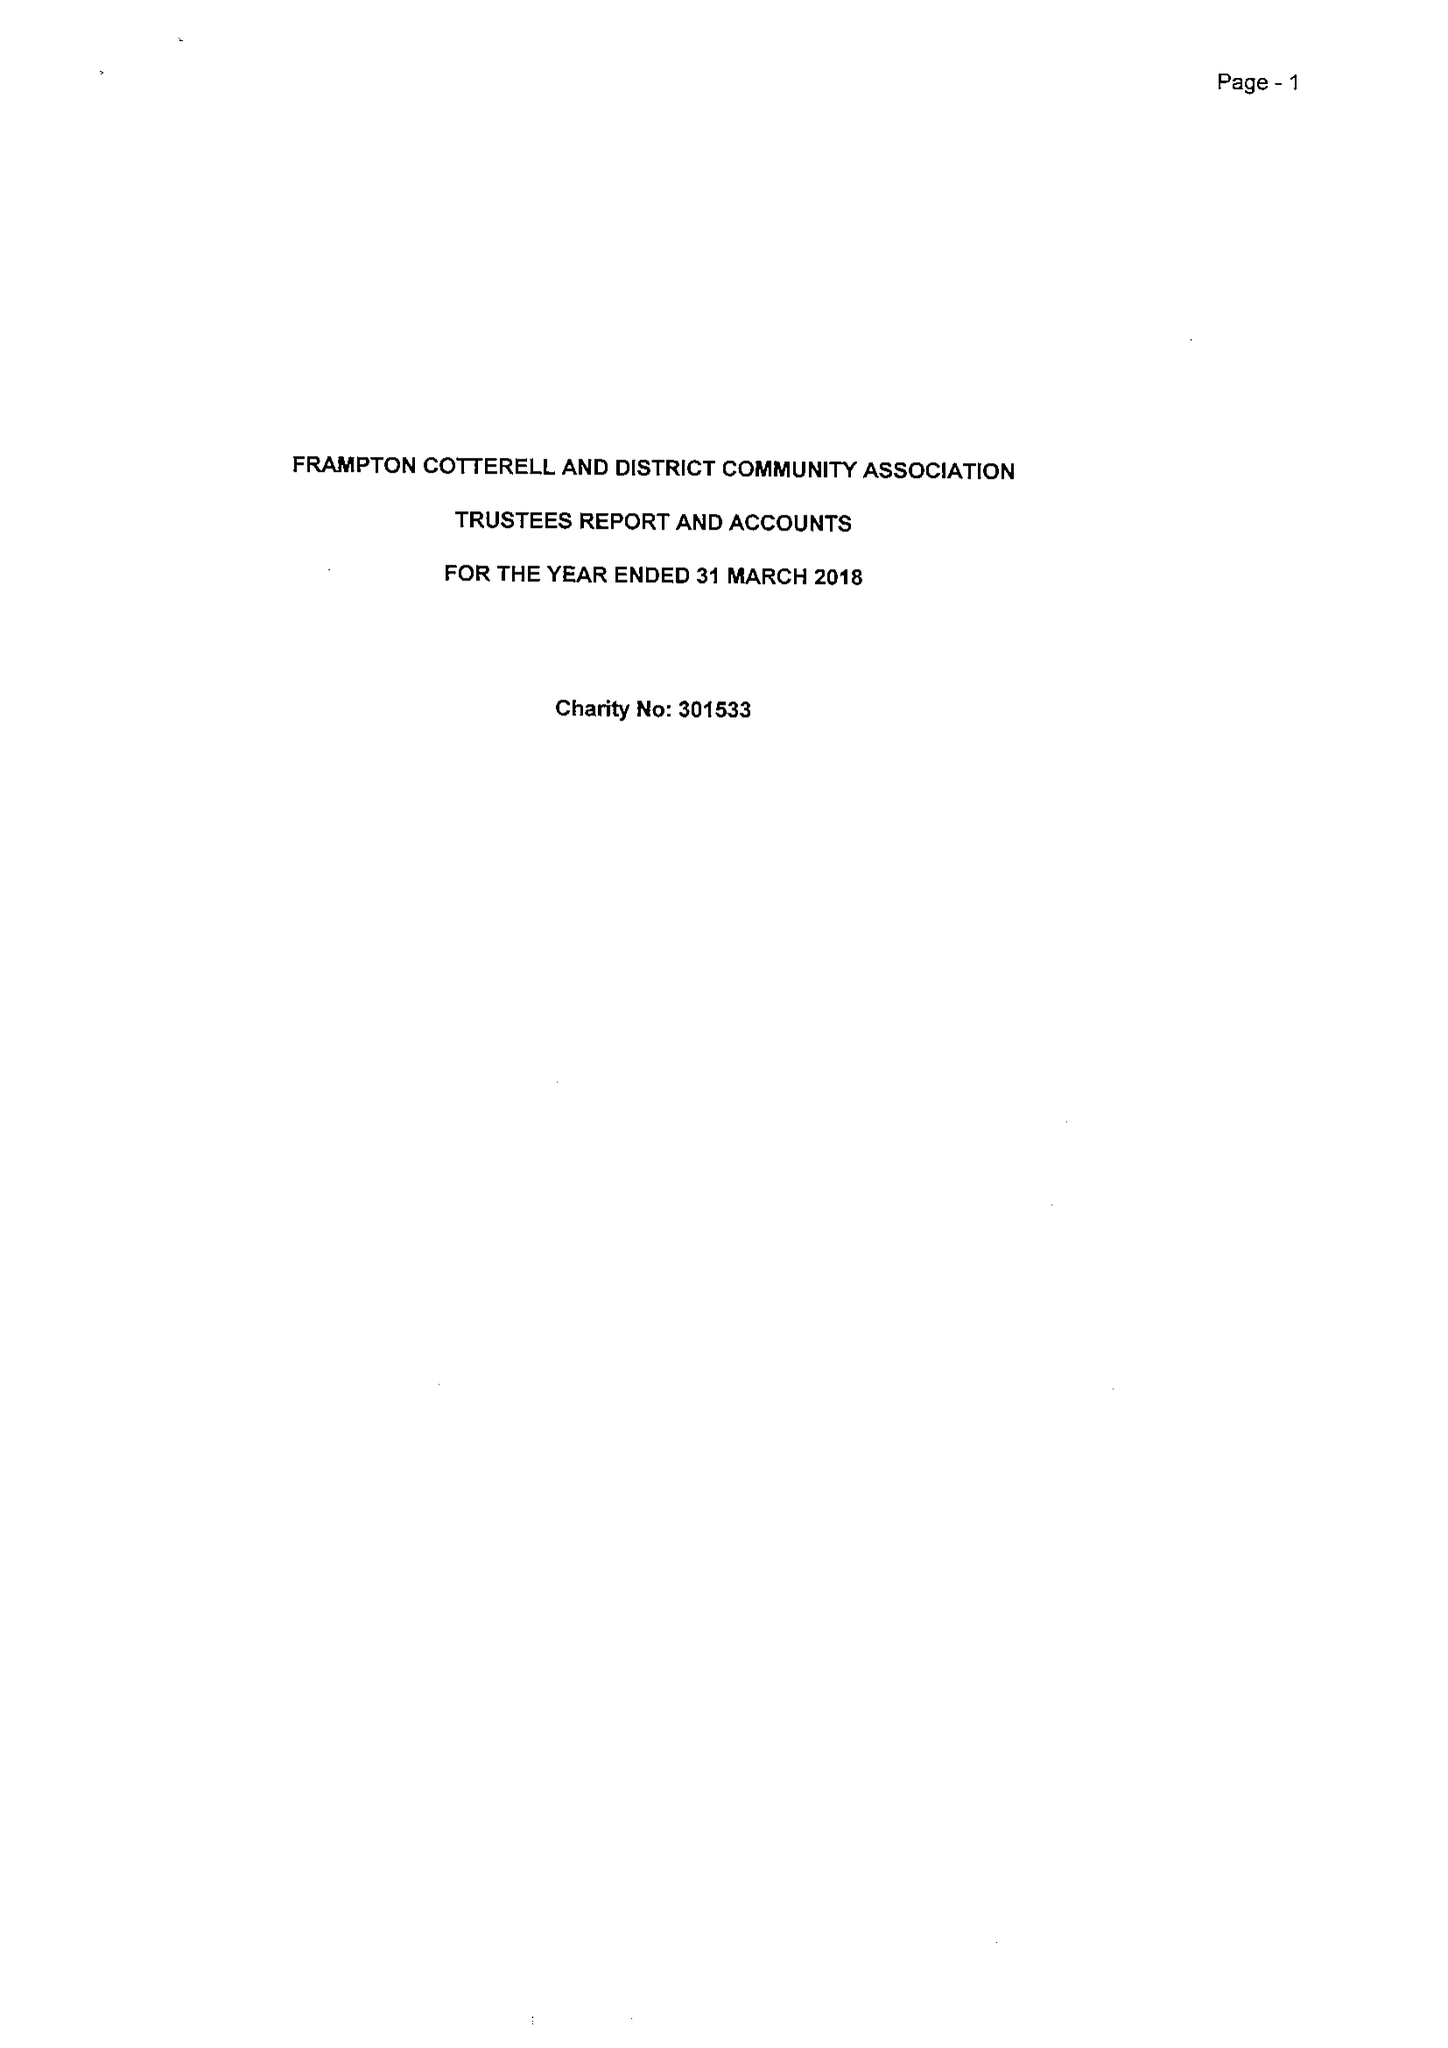What is the value for the address__street_line?
Answer the question using a single word or phrase. 35 SCHOOL ROAD 